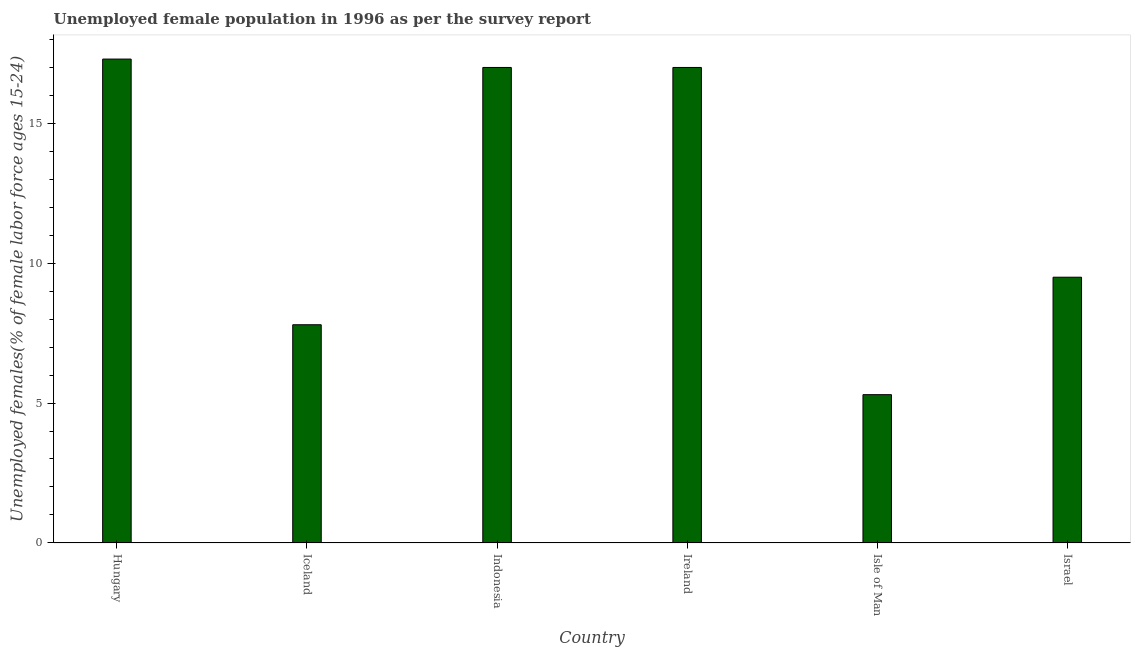Does the graph contain any zero values?
Provide a short and direct response. No. Does the graph contain grids?
Provide a short and direct response. No. What is the title of the graph?
Your response must be concise. Unemployed female population in 1996 as per the survey report. What is the label or title of the X-axis?
Your answer should be very brief. Country. What is the label or title of the Y-axis?
Make the answer very short. Unemployed females(% of female labor force ages 15-24). What is the unemployed female youth in Isle of Man?
Give a very brief answer. 5.3. Across all countries, what is the maximum unemployed female youth?
Offer a terse response. 17.3. Across all countries, what is the minimum unemployed female youth?
Provide a succinct answer. 5.3. In which country was the unemployed female youth maximum?
Your answer should be very brief. Hungary. In which country was the unemployed female youth minimum?
Your answer should be very brief. Isle of Man. What is the sum of the unemployed female youth?
Your response must be concise. 73.9. What is the average unemployed female youth per country?
Offer a terse response. 12.32. What is the median unemployed female youth?
Provide a succinct answer. 13.25. What is the ratio of the unemployed female youth in Indonesia to that in Israel?
Provide a short and direct response. 1.79. Is the unemployed female youth in Ireland less than that in Isle of Man?
Offer a very short reply. No. What is the difference between the highest and the second highest unemployed female youth?
Keep it short and to the point. 0.3. Is the sum of the unemployed female youth in Hungary and Iceland greater than the maximum unemployed female youth across all countries?
Your answer should be very brief. Yes. How many bars are there?
Provide a short and direct response. 6. How many countries are there in the graph?
Your answer should be compact. 6. What is the difference between two consecutive major ticks on the Y-axis?
Keep it short and to the point. 5. What is the Unemployed females(% of female labor force ages 15-24) of Hungary?
Keep it short and to the point. 17.3. What is the Unemployed females(% of female labor force ages 15-24) in Iceland?
Keep it short and to the point. 7.8. What is the Unemployed females(% of female labor force ages 15-24) in Isle of Man?
Offer a very short reply. 5.3. What is the Unemployed females(% of female labor force ages 15-24) of Israel?
Offer a very short reply. 9.5. What is the difference between the Unemployed females(% of female labor force ages 15-24) in Hungary and Iceland?
Give a very brief answer. 9.5. What is the difference between the Unemployed females(% of female labor force ages 15-24) in Hungary and Israel?
Provide a short and direct response. 7.8. What is the difference between the Unemployed females(% of female labor force ages 15-24) in Iceland and Indonesia?
Offer a very short reply. -9.2. What is the difference between the Unemployed females(% of female labor force ages 15-24) in Iceland and Ireland?
Your answer should be compact. -9.2. What is the ratio of the Unemployed females(% of female labor force ages 15-24) in Hungary to that in Iceland?
Offer a very short reply. 2.22. What is the ratio of the Unemployed females(% of female labor force ages 15-24) in Hungary to that in Isle of Man?
Keep it short and to the point. 3.26. What is the ratio of the Unemployed females(% of female labor force ages 15-24) in Hungary to that in Israel?
Provide a short and direct response. 1.82. What is the ratio of the Unemployed females(% of female labor force ages 15-24) in Iceland to that in Indonesia?
Your answer should be very brief. 0.46. What is the ratio of the Unemployed females(% of female labor force ages 15-24) in Iceland to that in Ireland?
Your response must be concise. 0.46. What is the ratio of the Unemployed females(% of female labor force ages 15-24) in Iceland to that in Isle of Man?
Provide a succinct answer. 1.47. What is the ratio of the Unemployed females(% of female labor force ages 15-24) in Iceland to that in Israel?
Keep it short and to the point. 0.82. What is the ratio of the Unemployed females(% of female labor force ages 15-24) in Indonesia to that in Ireland?
Make the answer very short. 1. What is the ratio of the Unemployed females(% of female labor force ages 15-24) in Indonesia to that in Isle of Man?
Your answer should be very brief. 3.21. What is the ratio of the Unemployed females(% of female labor force ages 15-24) in Indonesia to that in Israel?
Your answer should be compact. 1.79. What is the ratio of the Unemployed females(% of female labor force ages 15-24) in Ireland to that in Isle of Man?
Your response must be concise. 3.21. What is the ratio of the Unemployed females(% of female labor force ages 15-24) in Ireland to that in Israel?
Ensure brevity in your answer.  1.79. What is the ratio of the Unemployed females(% of female labor force ages 15-24) in Isle of Man to that in Israel?
Your answer should be very brief. 0.56. 